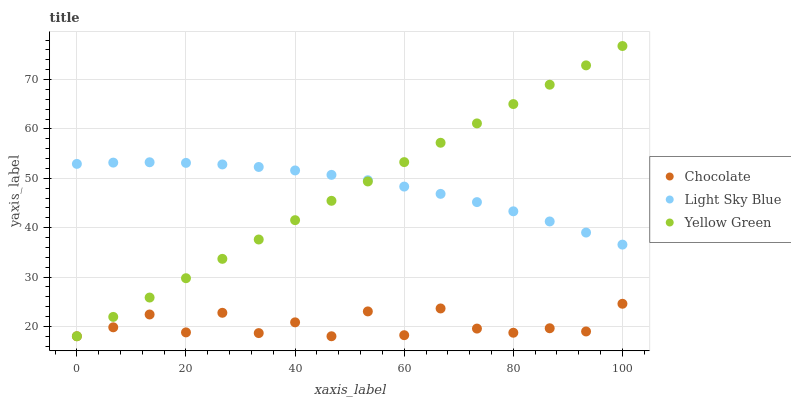Does Chocolate have the minimum area under the curve?
Answer yes or no. Yes. Does Light Sky Blue have the maximum area under the curve?
Answer yes or no. Yes. Does Yellow Green have the minimum area under the curve?
Answer yes or no. No. Does Yellow Green have the maximum area under the curve?
Answer yes or no. No. Is Yellow Green the smoothest?
Answer yes or no. Yes. Is Chocolate the roughest?
Answer yes or no. Yes. Is Chocolate the smoothest?
Answer yes or no. No. Is Yellow Green the roughest?
Answer yes or no. No. Does Yellow Green have the lowest value?
Answer yes or no. Yes. Does Yellow Green have the highest value?
Answer yes or no. Yes. Does Chocolate have the highest value?
Answer yes or no. No. Is Chocolate less than Light Sky Blue?
Answer yes or no. Yes. Is Light Sky Blue greater than Chocolate?
Answer yes or no. Yes. Does Chocolate intersect Yellow Green?
Answer yes or no. Yes. Is Chocolate less than Yellow Green?
Answer yes or no. No. Is Chocolate greater than Yellow Green?
Answer yes or no. No. Does Chocolate intersect Light Sky Blue?
Answer yes or no. No. 